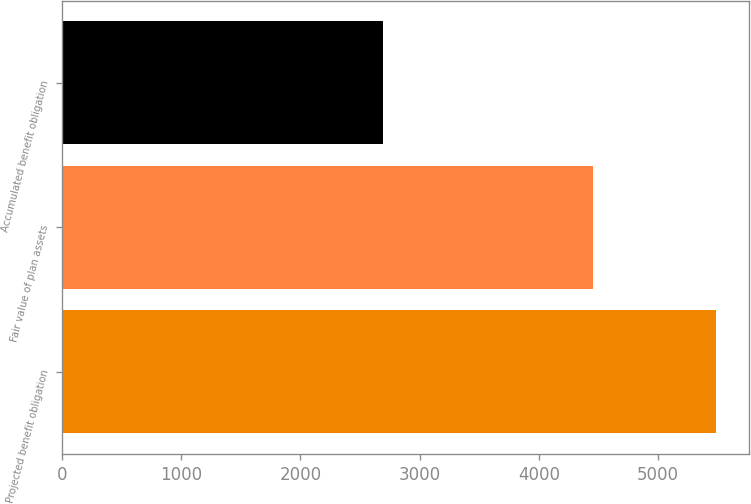Convert chart. <chart><loc_0><loc_0><loc_500><loc_500><bar_chart><fcel>Projected benefit obligation<fcel>Fair value of plan assets<fcel>Accumulated benefit obligation<nl><fcel>5486<fcel>4457<fcel>2692<nl></chart> 